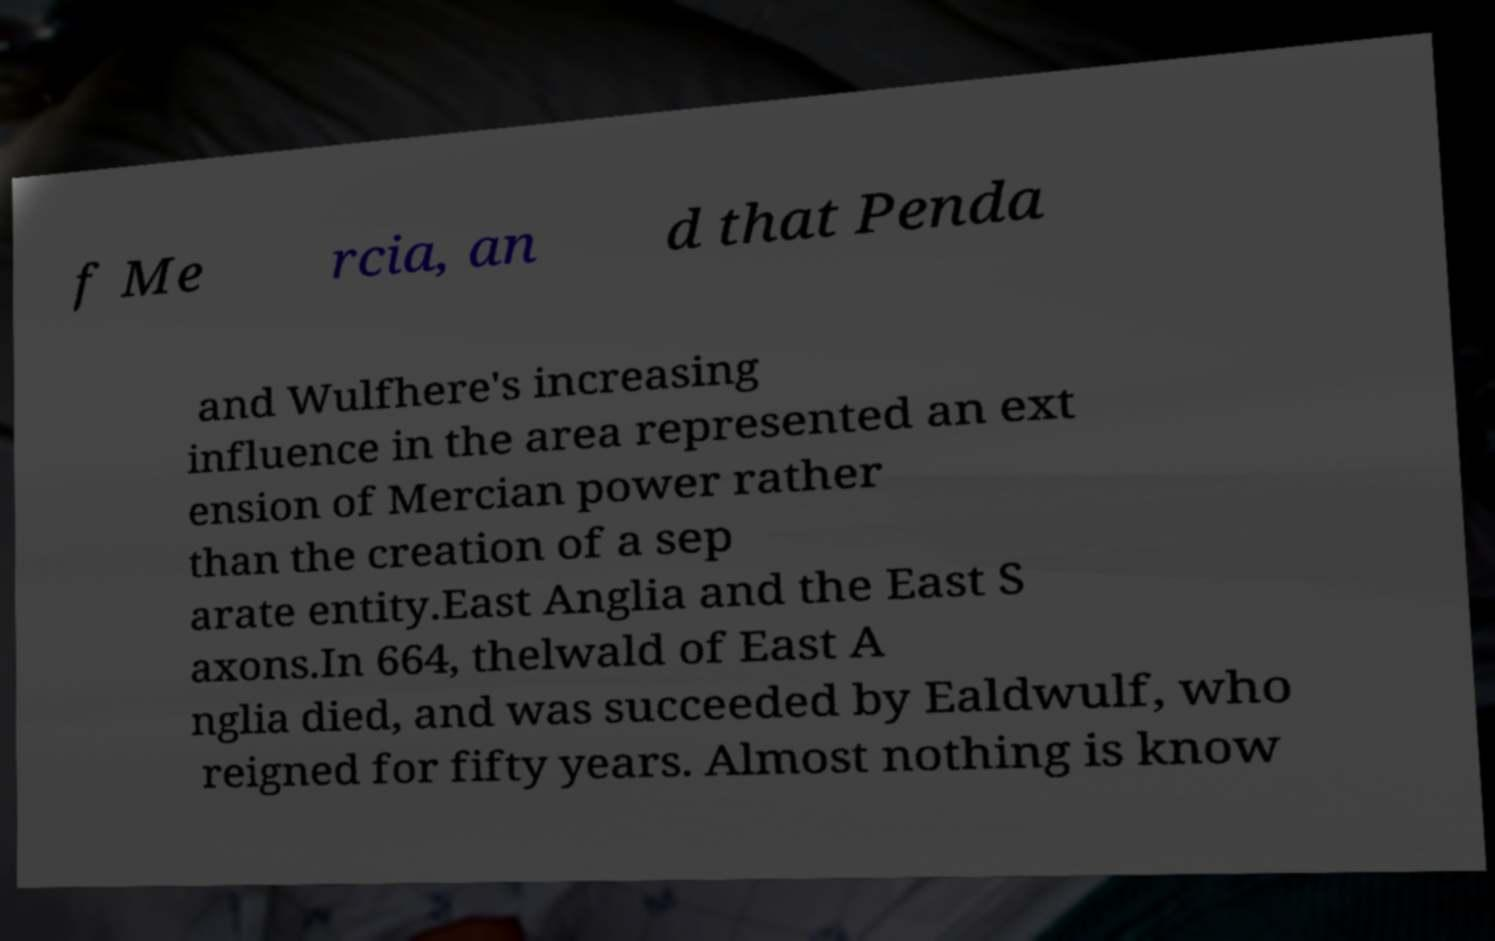What messages or text are displayed in this image? I need them in a readable, typed format. f Me rcia, an d that Penda and Wulfhere's increasing influence in the area represented an ext ension of Mercian power rather than the creation of a sep arate entity.East Anglia and the East S axons.In 664, thelwald of East A nglia died, and was succeeded by Ealdwulf, who reigned for fifty years. Almost nothing is know 